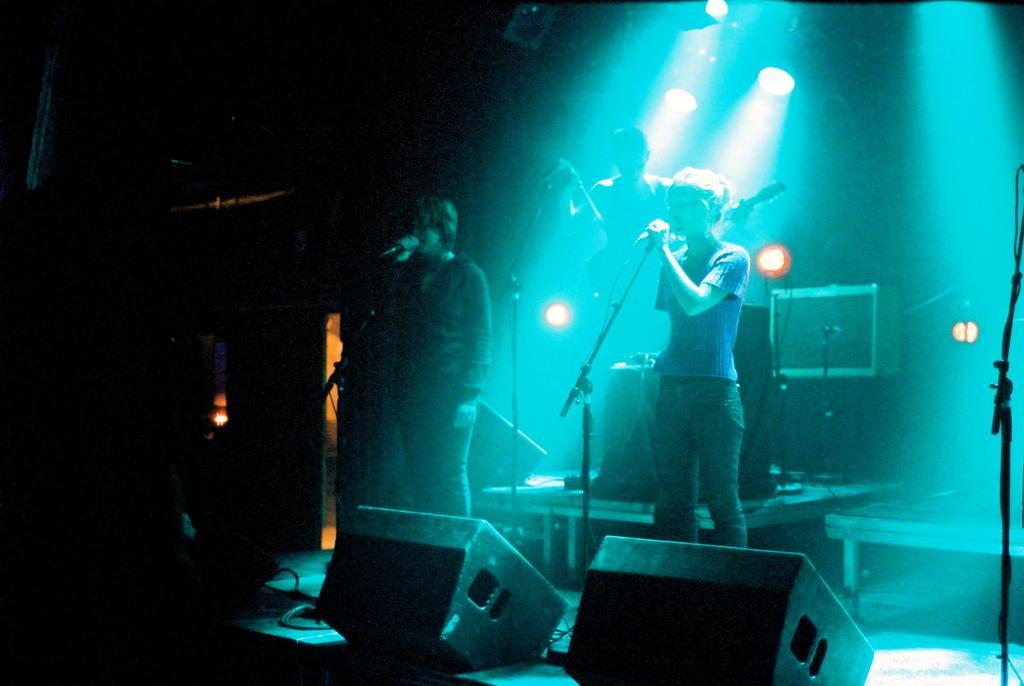In one or two sentences, can you explain what this image depicts? This is a picture of a concert. In the center of the picture there are two women singing into microphones, behind them there are speakers, microphone, focus lights, boxes and a person playing guitar. In the foreground there are cables and lights. On the left it is dark. In the background, towards left there is a door. On the right there is a microphone and a table. 